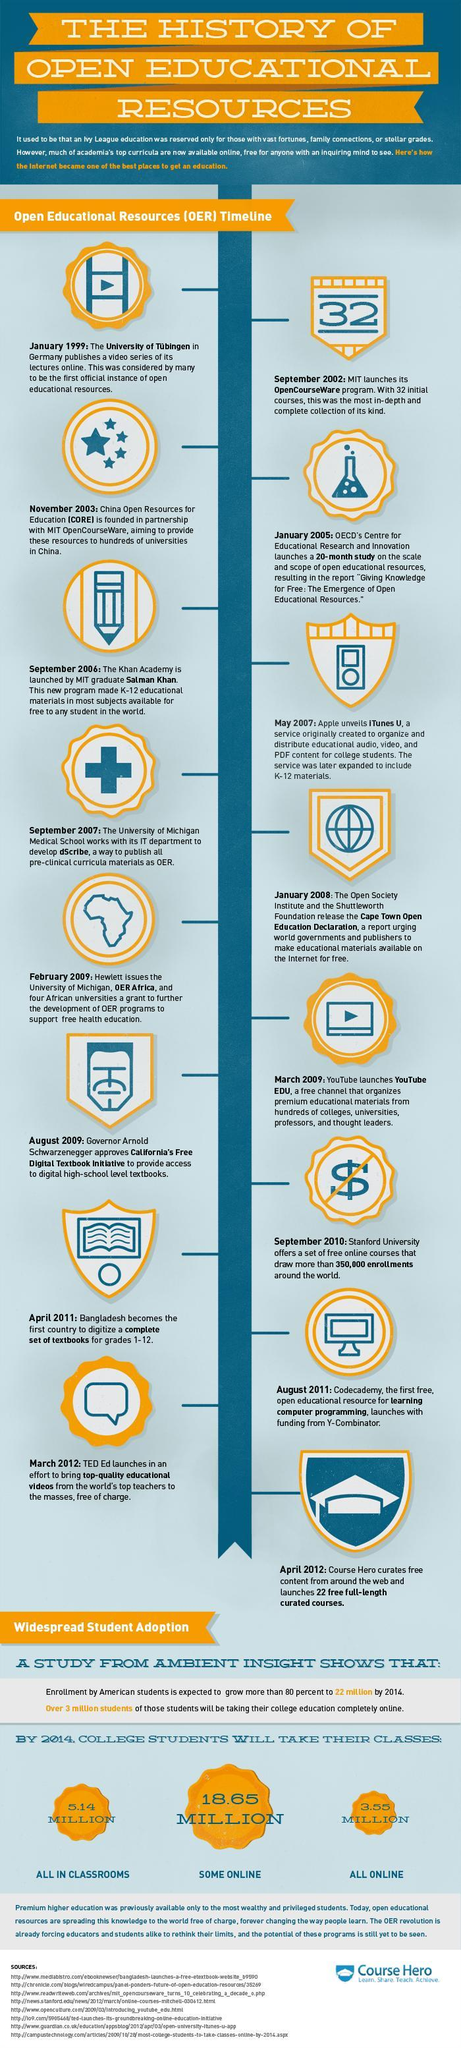How many sources are listed at the bottom?
Answer the question with a short phrase. 8 